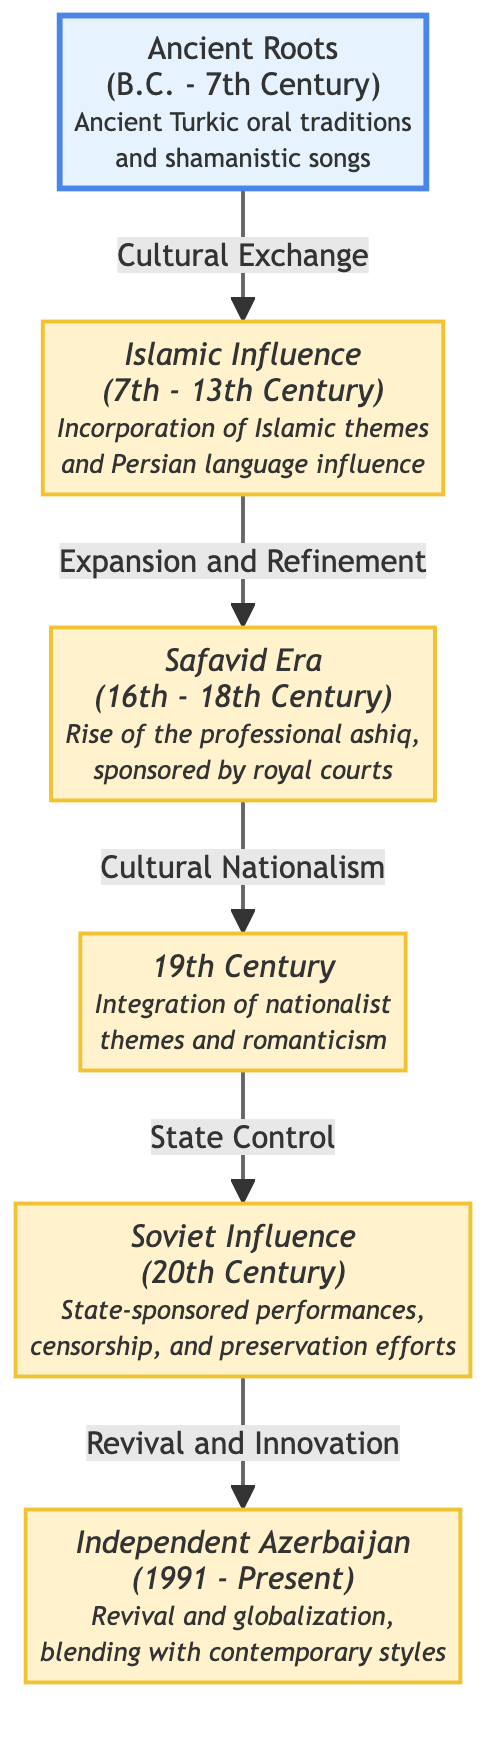What is the earliest era depicted in the diagram? The diagram shows six eras, and the first one listed is "Ancient Roots" which spans from B.C. to the 7th Century, making it the earliest era.
Answer: Ancient Roots How many key eras are represented in this diagram? Counting the nodes in the diagram indicates there are a total of six key eras represented.
Answer: 6 What influence is associated with the period from the 7th to the 13th Century? The diagram indicates that this period is associated with "Islamic Influence," which incorporates Islamic themes and Persian language influence.
Answer: Islamic Influence Which era is characterized by state-sponsored performances and censorship? The diagram shows that the "Soviet Influence" era of the 20th Century is characterized by state-sponsored performances, censorship, and preservation efforts.
Answer: Soviet Influence What is the transitional phrase between the "Safavid Era" and the "19th Century"? According to the diagram, the transition from "Safavid Era" to the "19th Century" is described with the phrase "Cultural Nationalism."
Answer: Cultural Nationalism Which era follows the "19th Century" in the timeline? The diagram indicates that the era following the "19th Century" is "Soviet Influence," which occurred in the 20th Century.
Answer: Soviet Influence What key theme is integrated during the "19th Century"? The diagram specifies that during the "19th Century," there was an integration of "nationalist themes and romanticism."
Answer: Nationalist themes and romanticism What is the relationship between the "Islamic Influence" and "Safavid Era"? The relationship shown between the "Islamic Influence" and the "Safavid Era" is one of "Expansion and Refinement," indicating a development in musical and poetic traditions.
Answer: Expansion and Refinement What is the main focus of the "Independent Azerbaijan" era? The diagram depicts that the main focus during the "Independent Azerbaijan" era is the "Revival and globalization, blending with contemporary styles."
Answer: Revival and globalization, blending with contemporary styles 